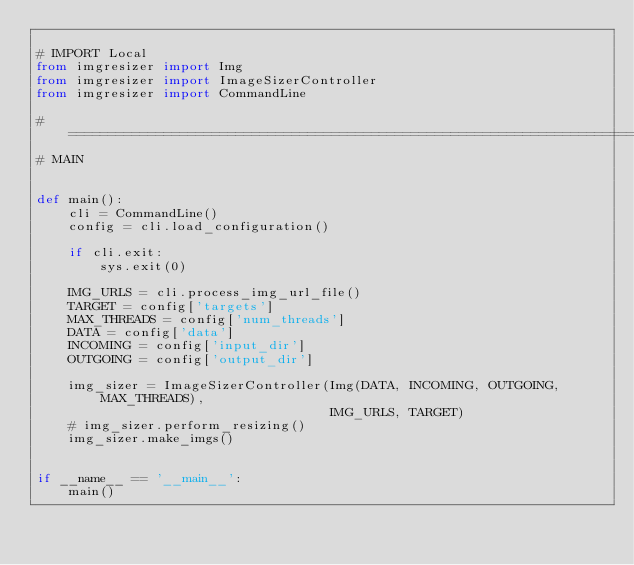<code> <loc_0><loc_0><loc_500><loc_500><_Python_>
# IMPORT Local
from imgresizer import Img
from imgresizer import ImageSizerController
from imgresizer import CommandLine

# =============================================================================
# MAIN


def main():
    cli = CommandLine()
    config = cli.load_configuration()

    if cli.exit:
        sys.exit(0)

    IMG_URLS = cli.process_img_url_file()
    TARGET = config['targets']
    MAX_THREADS = config['num_threads']
    DATA = config['data']
    INCOMING = config['input_dir']
    OUTGOING = config['output_dir']

    img_sizer = ImageSizerController(Img(DATA, INCOMING, OUTGOING, MAX_THREADS),
                                     IMG_URLS, TARGET)
    # img_sizer.perform_resizing()
    img_sizer.make_imgs()


if __name__ == '__main__':
    main()
</code> 